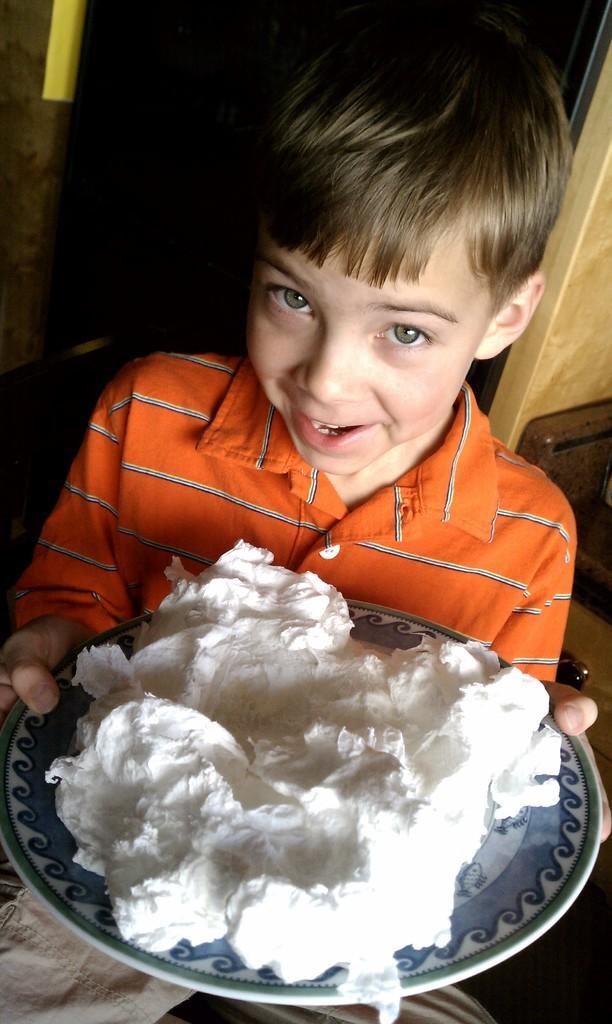Describe this image in one or two sentences. In this picture we can see a boy holding a plate with his hand and smiling and on this plate we can see white cream and in the background we can see some objects and it is dark. 